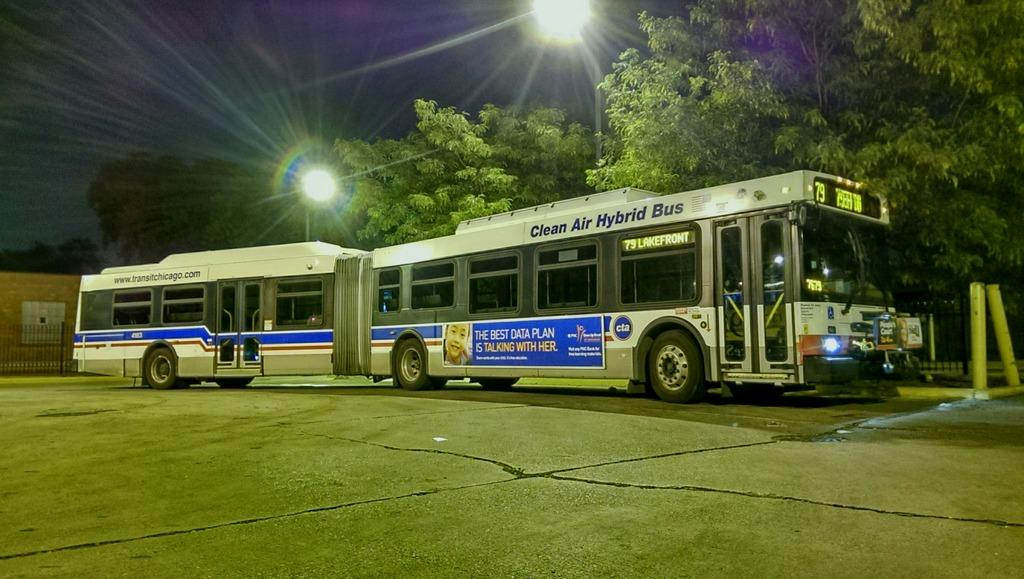What type of vehicle is on the road in the image? There is a bus on the road in the image. What can be seen illuminated in the image? There are lights visible in the image. What type of natural vegetation surrounds the area in the image? There are trees surrounding the area in the image. What type of barrier is present in the image? There is a metal fence in the image. What is visible at the top of the image? The sky is visible at the top of the image. How many boys are wearing caps and eating jelly in the image? There are no boys, caps, or jelly present in the image. 